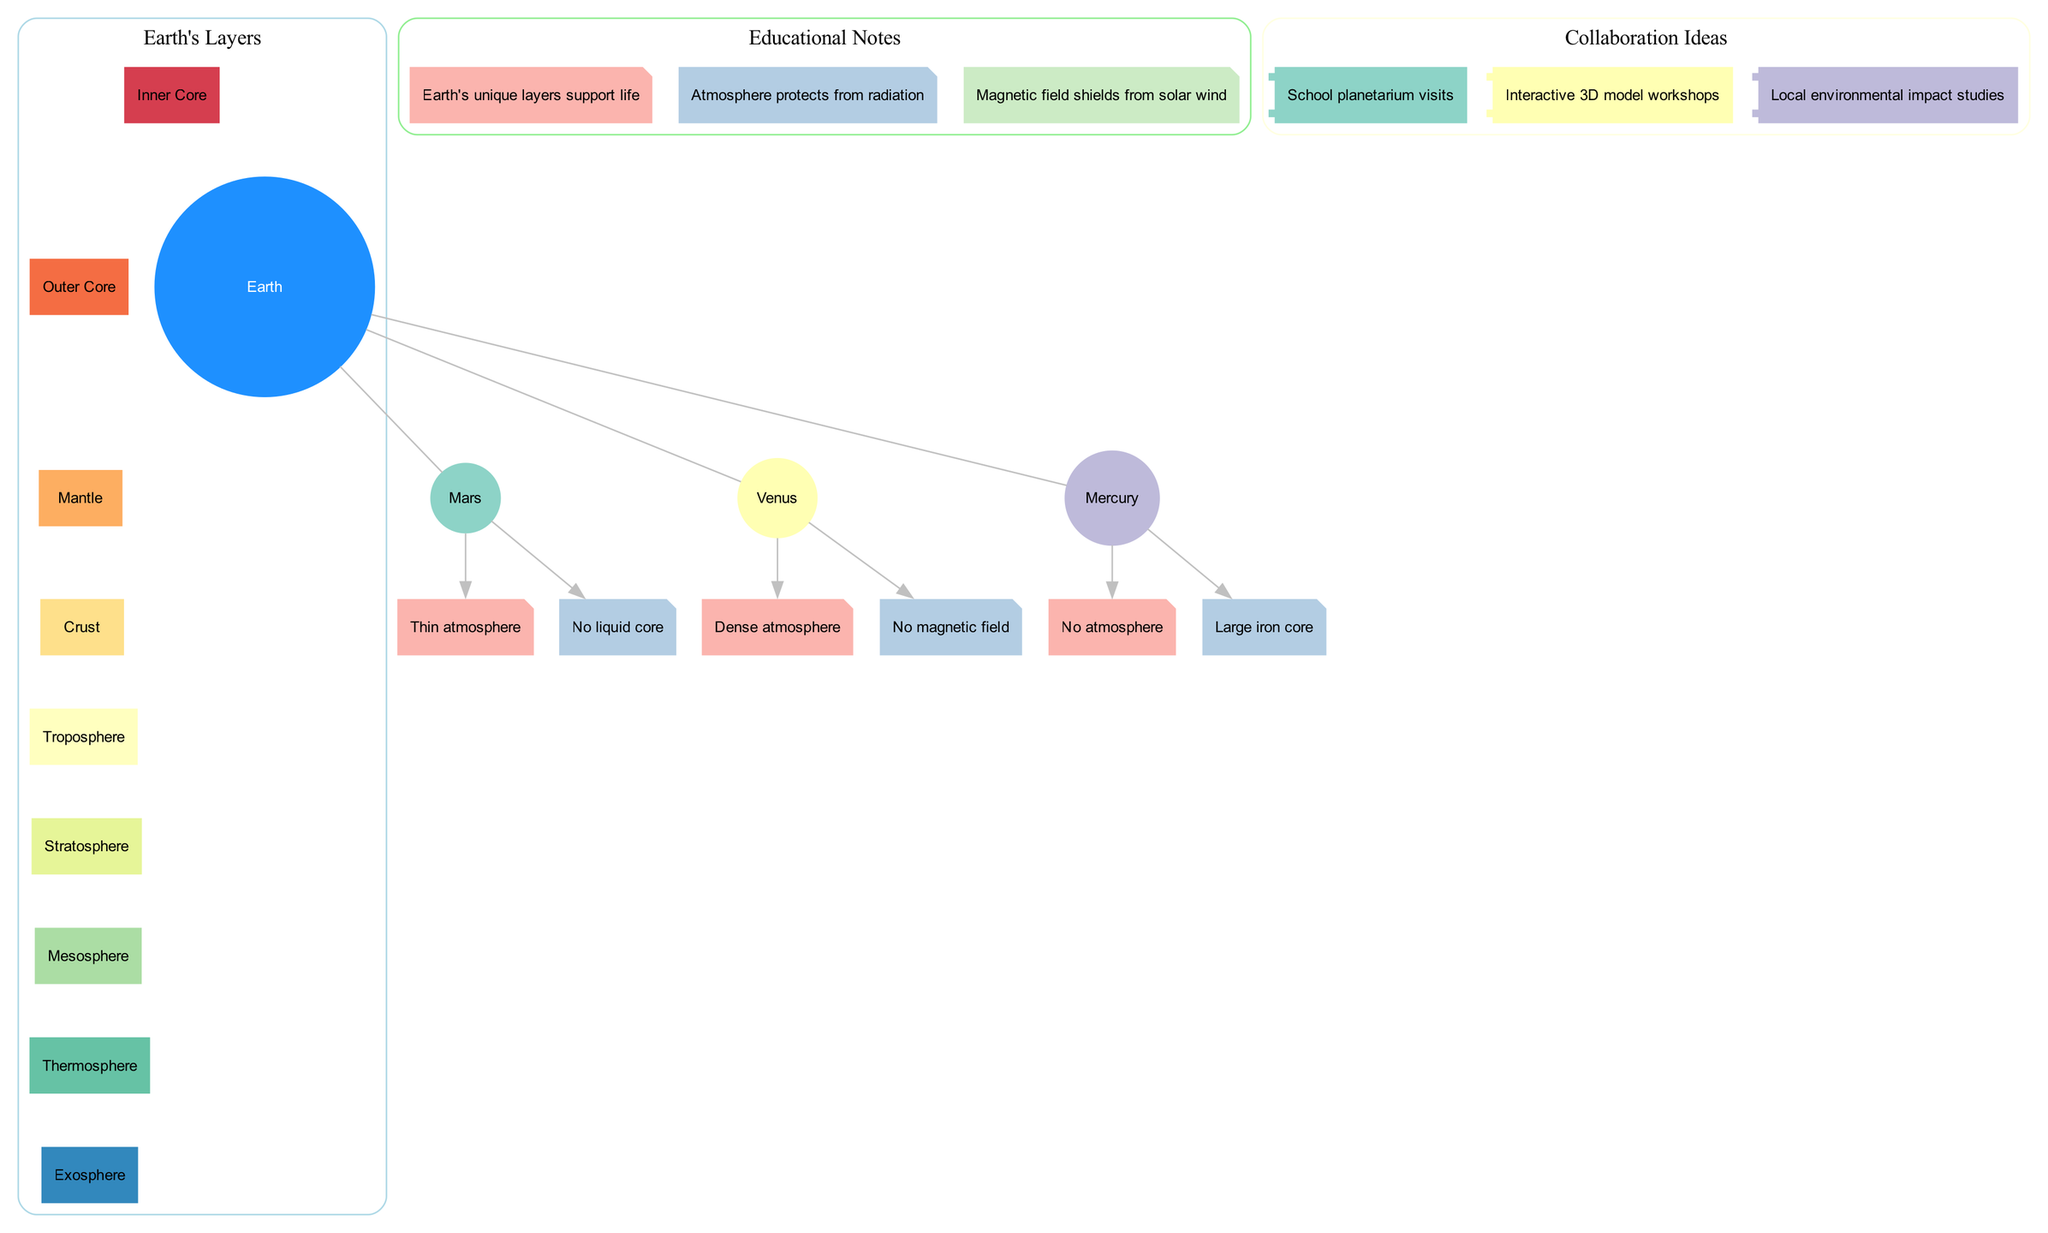What is the top layer of Earth's atmosphere? The diagram lists the layers of Earth's atmosphere, with the topmost layer shown at the start of the list as "Exosphere."
Answer: Exosphere How many layers are present in the Earth's structure? The diagram lists the layers of Earth, totaling eight distinct layers from the Exosphere down to the Inner Core.
Answer: 8 Which terrestrial planet has no atmosphere? The diagram indicates that Mercury is the only terrestrial planet listed that features "No atmosphere" in its key features.
Answer: Mercury What is one key feature of Mars? The diagram specifies "Thin atmosphere" as one of the key features of Mars, directly linking it to the planet in the comparison section.
Answer: Thin atmosphere How does Earth's atmosphere provide protection? Referring to the educational notes, the diagram states that "Atmosphere protects from radiation," which indicates a protective function of Earth's atmosphere.
Answer: Protects from radiation What feature distinguishes Venus from other planets in the diagram? The diagram highlights that Venus has a "Dense atmosphere" and "No magnetic field," making these features unique when compared to Earth and the other terrestrial planets.
Answer: Dense atmosphere Which layer of Earth directly supports life? According to the educational notes included in the diagram, "Earth's unique layers support life," correlating this characteristic to the layers shown in the Earth's structure.
Answer: Crust What is one suggested collaboration idea listed in the diagram? The diagram presents various collaboration ideas, including "Interactive 3D model workshops," indicating an educational outreach approach.
Answer: Interactive 3D model workshops Which planet has a large iron core according to the data? The diagram specifies that Mercury is noted for having a "Large iron core," making it stand out among the terrestrial planets listed.
Answer: Mercury 